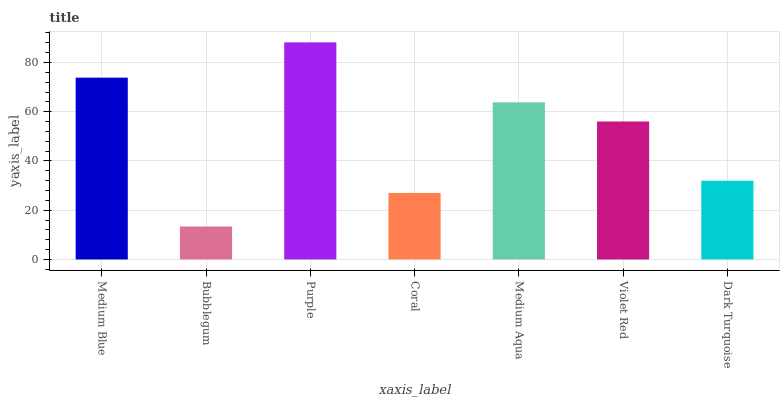Is Purple the minimum?
Answer yes or no. No. Is Bubblegum the maximum?
Answer yes or no. No. Is Purple greater than Bubblegum?
Answer yes or no. Yes. Is Bubblegum less than Purple?
Answer yes or no. Yes. Is Bubblegum greater than Purple?
Answer yes or no. No. Is Purple less than Bubblegum?
Answer yes or no. No. Is Violet Red the high median?
Answer yes or no. Yes. Is Violet Red the low median?
Answer yes or no. Yes. Is Medium Aqua the high median?
Answer yes or no. No. Is Medium Aqua the low median?
Answer yes or no. No. 